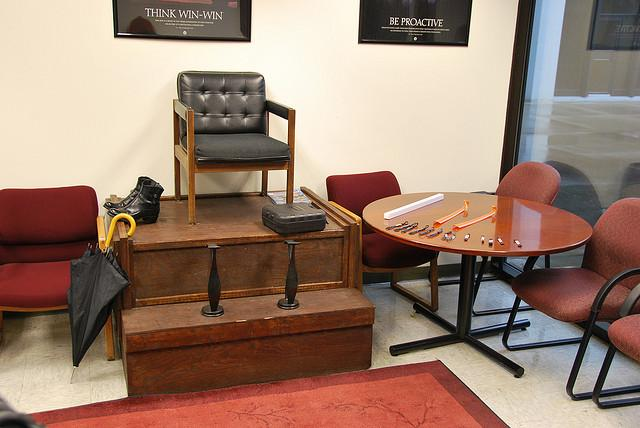What activity goes on in the chair on the platform?

Choices:
A) shoe shining
B) beard shaving
C) haircuts
D) scalp massage shoe shining 